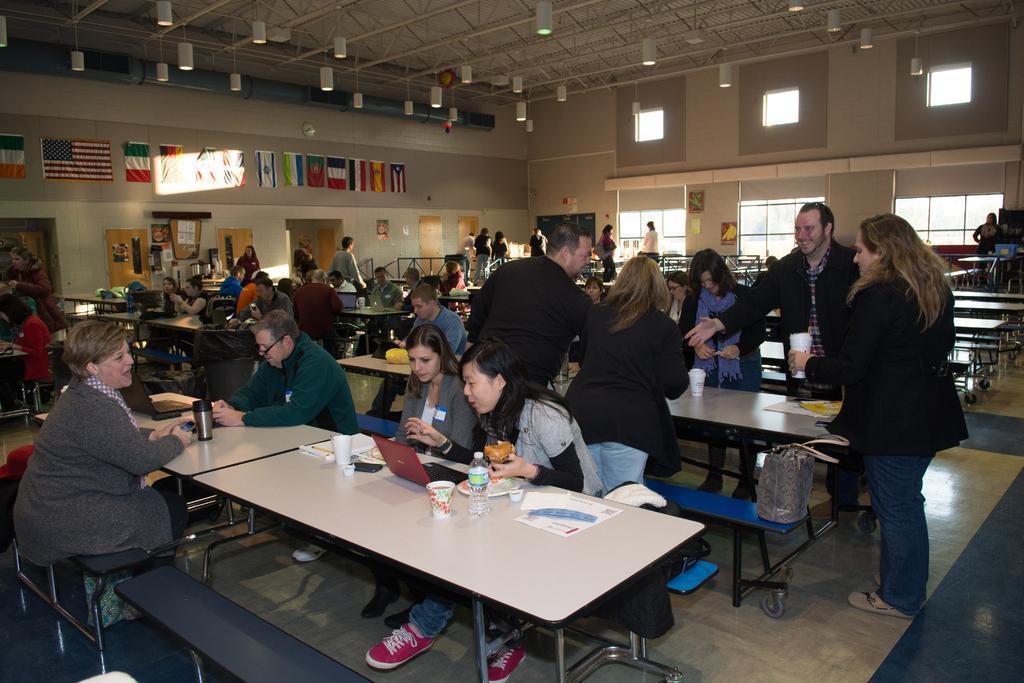Could you give a brief overview of what you see in this image? In a room there are so many chairs and tables arranged and at one table there are few people standing and on the other side of wall there flags stick which representing all the countries. Below that there is a display board in which some content has been sick and opposite to that there are so many windows on wall. 